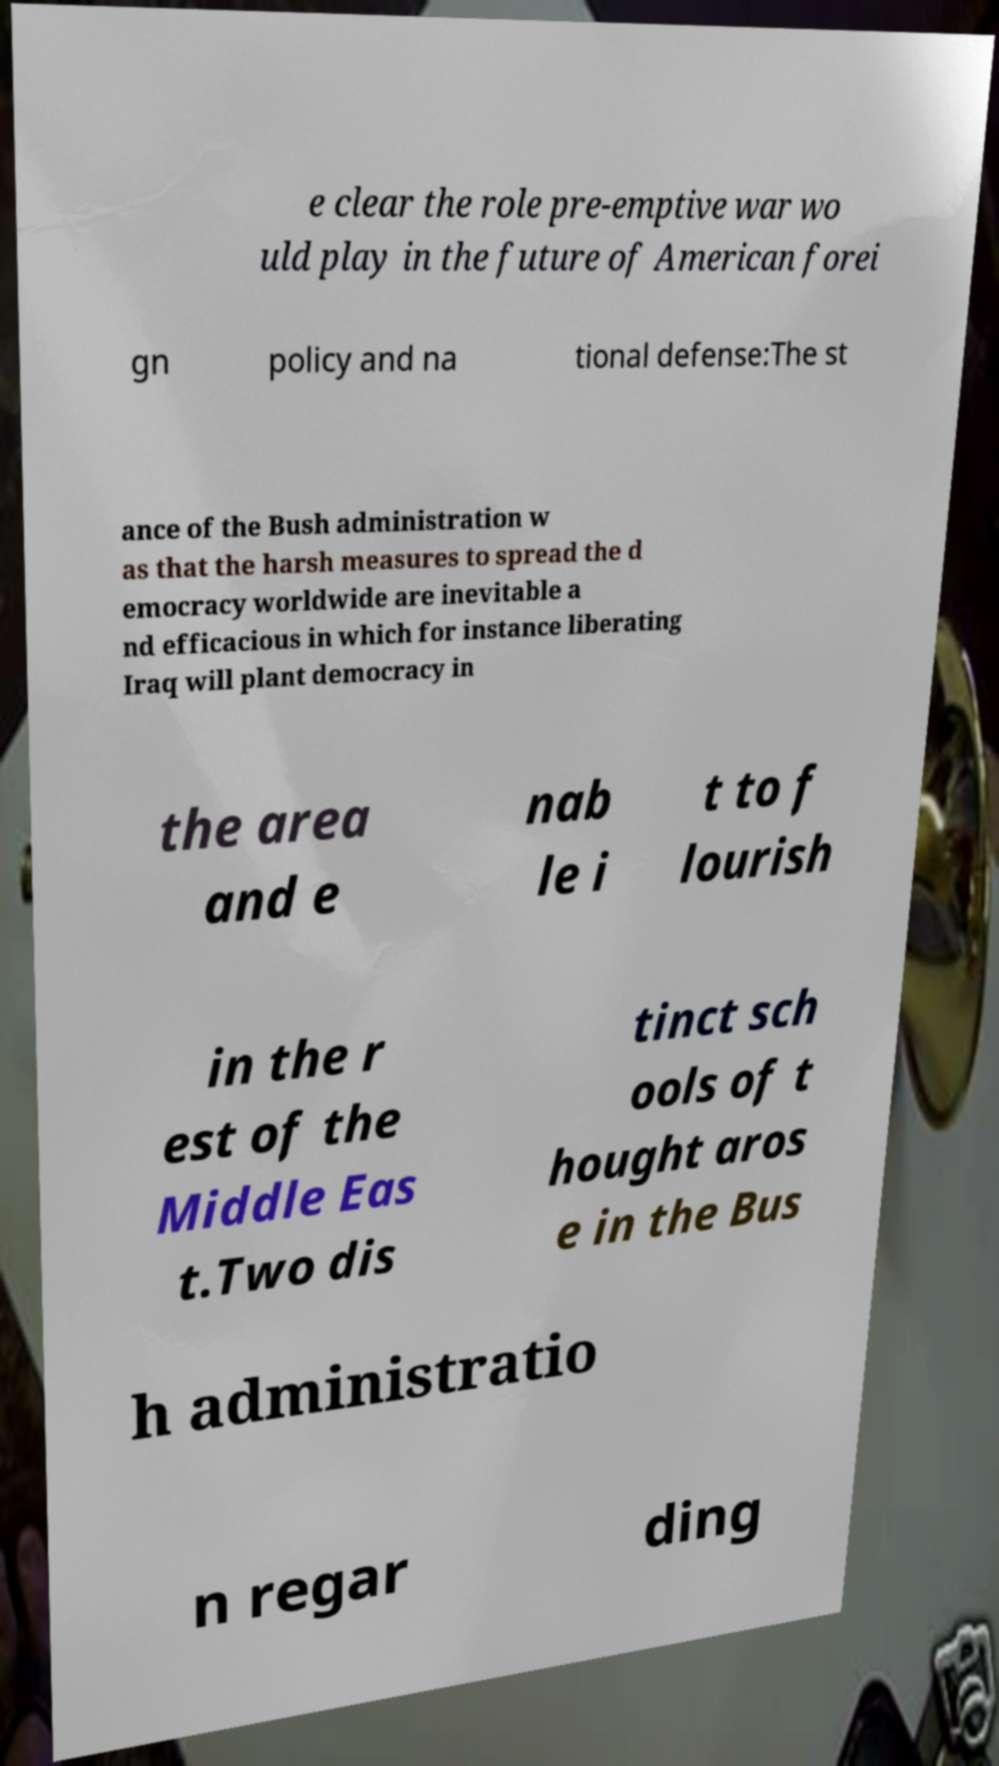There's text embedded in this image that I need extracted. Can you transcribe it verbatim? e clear the role pre-emptive war wo uld play in the future of American forei gn policy and na tional defense:The st ance of the Bush administration w as that the harsh measures to spread the d emocracy worldwide are inevitable a nd efficacious in which for instance liberating Iraq will plant democracy in the area and e nab le i t to f lourish in the r est of the Middle Eas t.Two dis tinct sch ools of t hought aros e in the Bus h administratio n regar ding 